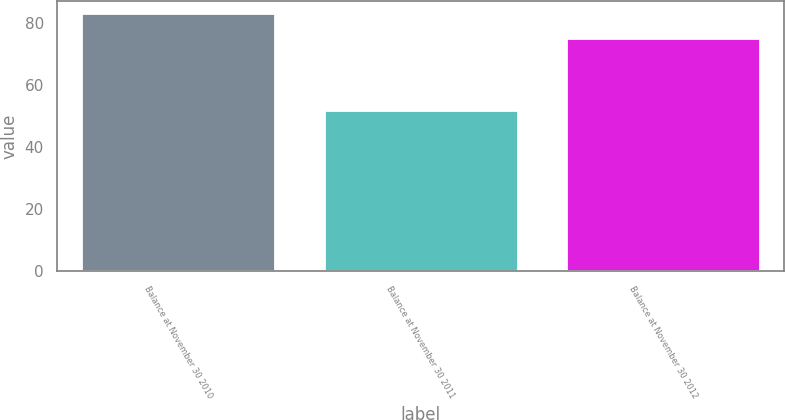Convert chart to OTSL. <chart><loc_0><loc_0><loc_500><loc_500><bar_chart><fcel>Balance at November 30 2010<fcel>Balance at November 30 2011<fcel>Balance at November 30 2012<nl><fcel>83<fcel>52<fcel>75<nl></chart> 